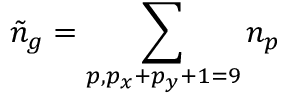Convert formula to latex. <formula><loc_0><loc_0><loc_500><loc_500>\tilde { n } _ { g } = \sum _ { p , p _ { x } + p _ { y } + 1 = 9 } n _ { p }</formula> 